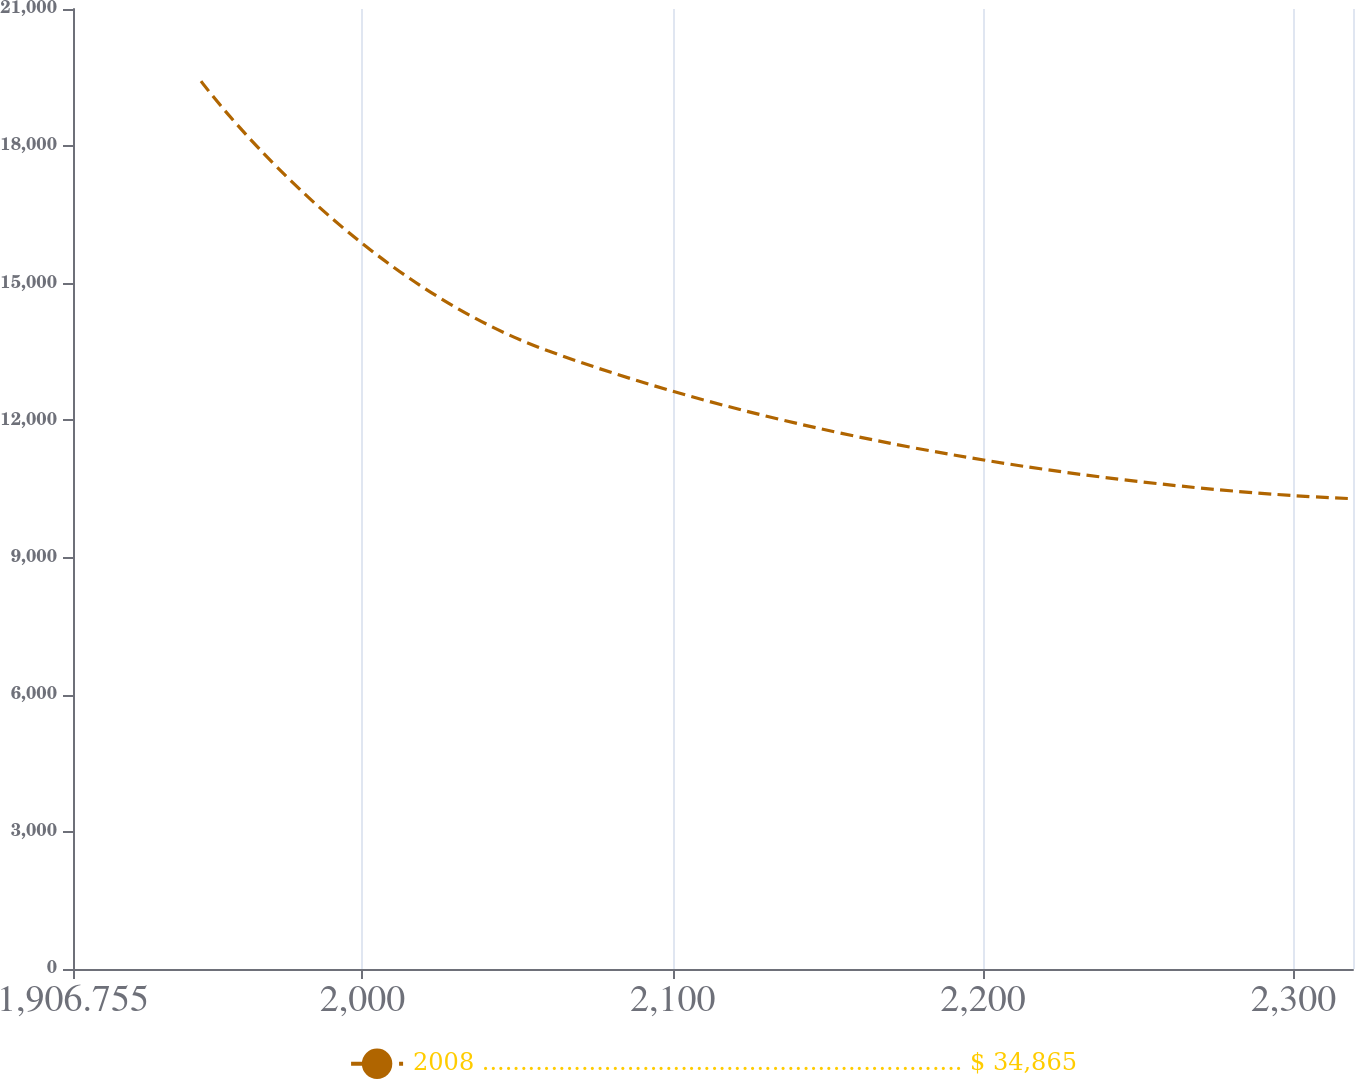<chart> <loc_0><loc_0><loc_500><loc_500><line_chart><ecel><fcel>2008 ............................................................... $ 34,865<nl><fcel>1948<fcel>19422.3<nl><fcel>2059.81<fcel>13522.8<nl><fcel>2318.94<fcel>10289.4<nl><fcel>2360.45<fcel>12148.7<nl></chart> 